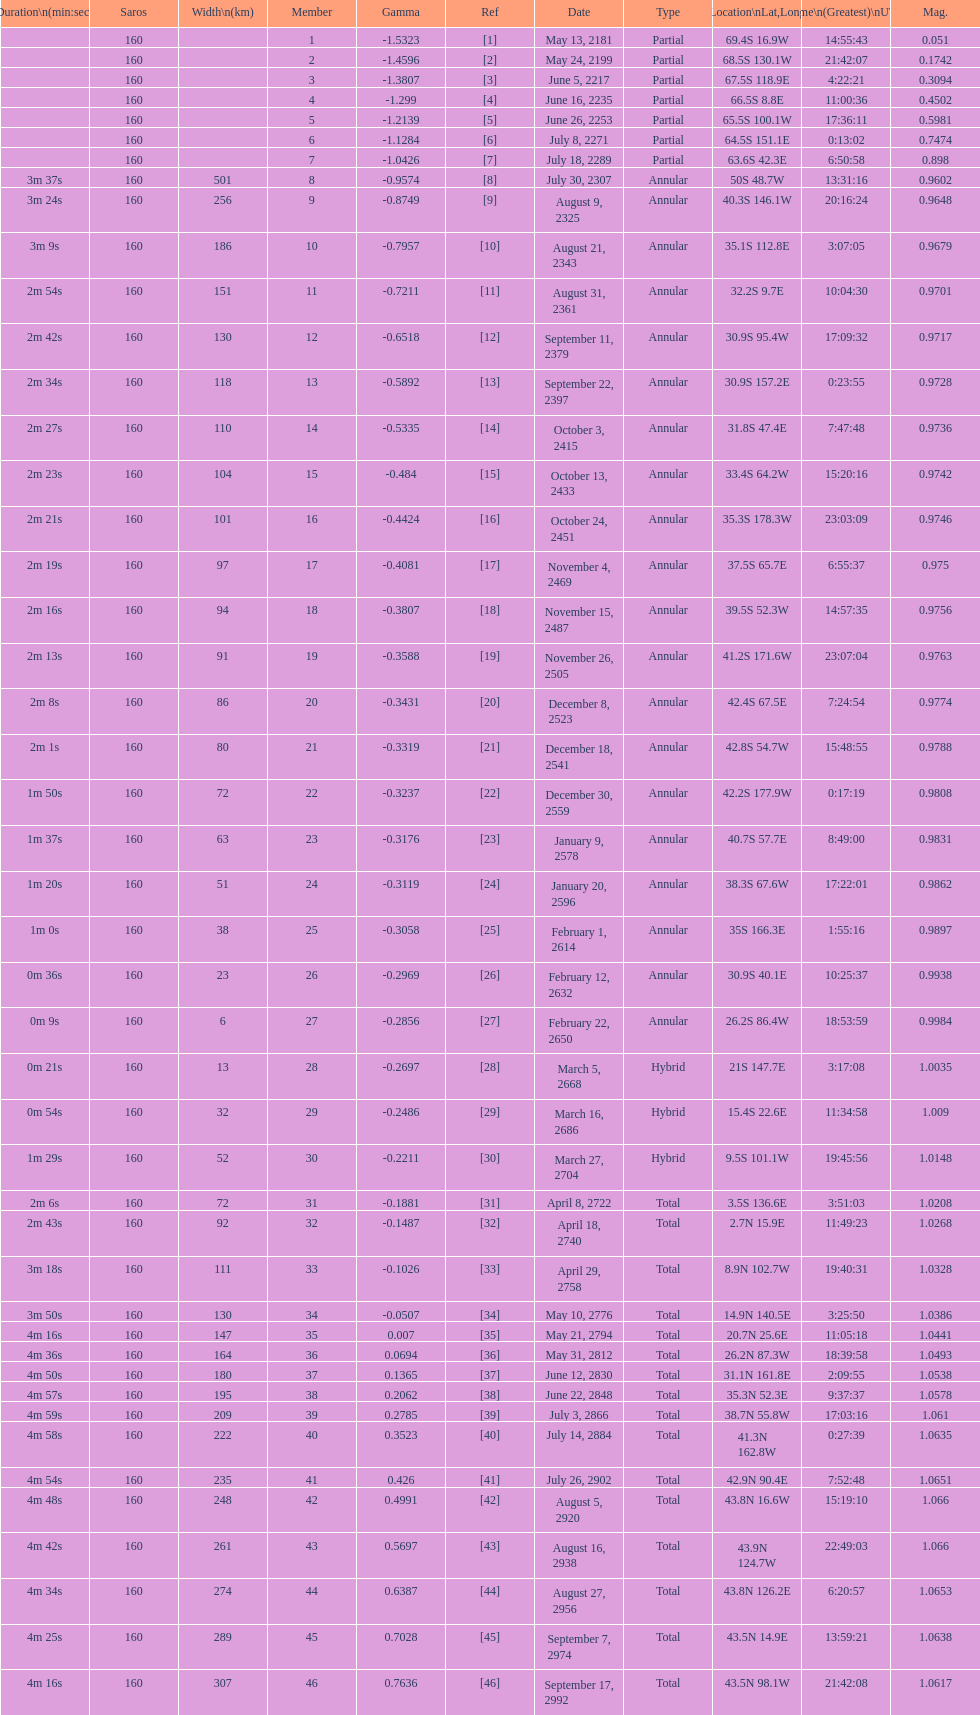How long did the the saros on july 30, 2307 last for? 3m 37s. 